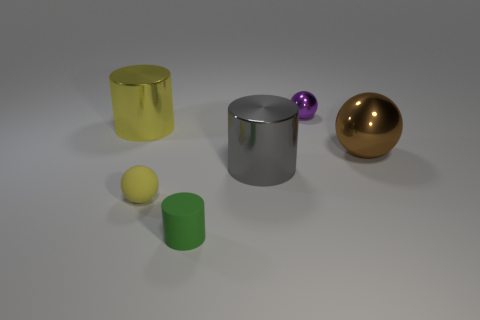What is the material of the large object that is behind the brown metallic sphere?
Offer a terse response. Metal. Does the big shiny cylinder that is on the right side of the tiny yellow matte sphere have the same color as the small metallic object?
Give a very brief answer. No. How big is the matte thing on the right side of the sphere that is in front of the large gray metallic thing?
Your response must be concise. Small. Are there more matte things in front of the small matte cylinder than tiny metal things?
Your answer should be very brief. No. There is a yellow object that is on the right side of the yellow metallic object; does it have the same size as the purple thing?
Offer a terse response. Yes. What is the color of the ball that is to the left of the large ball and behind the gray metal cylinder?
Your answer should be compact. Purple. What shape is the green matte object that is the same size as the purple shiny sphere?
Offer a very short reply. Cylinder. Are there any tiny cylinders of the same color as the tiny shiny sphere?
Your response must be concise. No. Are there an equal number of yellow things that are on the right side of the small matte cylinder and small green things?
Make the answer very short. No. Does the tiny matte cylinder have the same color as the tiny matte ball?
Provide a succinct answer. No. 